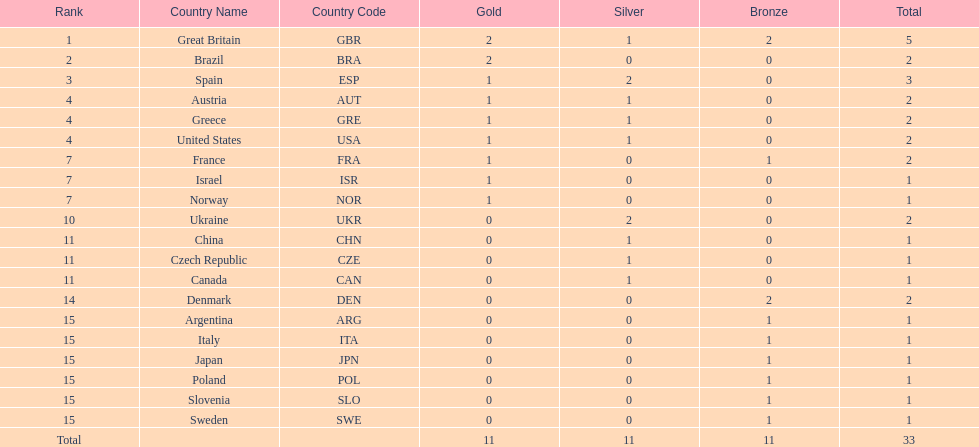How many countries won at least 1 gold and 1 silver medal? 5. 